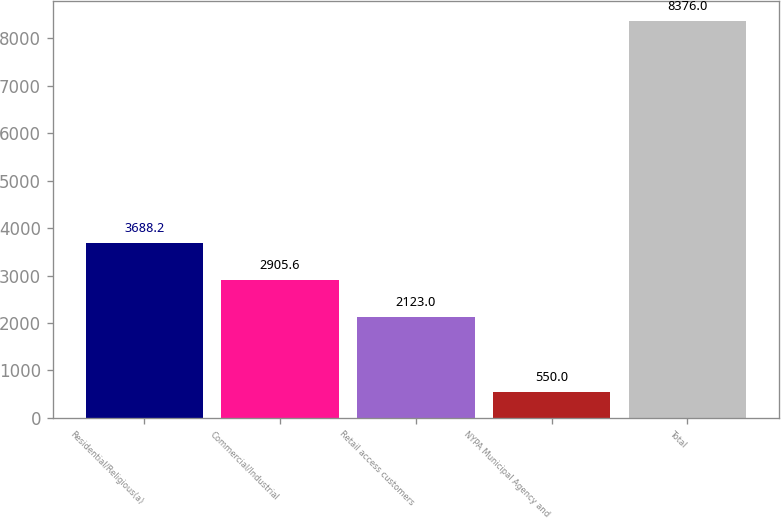Convert chart to OTSL. <chart><loc_0><loc_0><loc_500><loc_500><bar_chart><fcel>Residential/Religious(a)<fcel>Commercial/Industrial<fcel>Retail access customers<fcel>NYPA Municipal Agency and<fcel>Total<nl><fcel>3688.2<fcel>2905.6<fcel>2123<fcel>550<fcel>8376<nl></chart> 